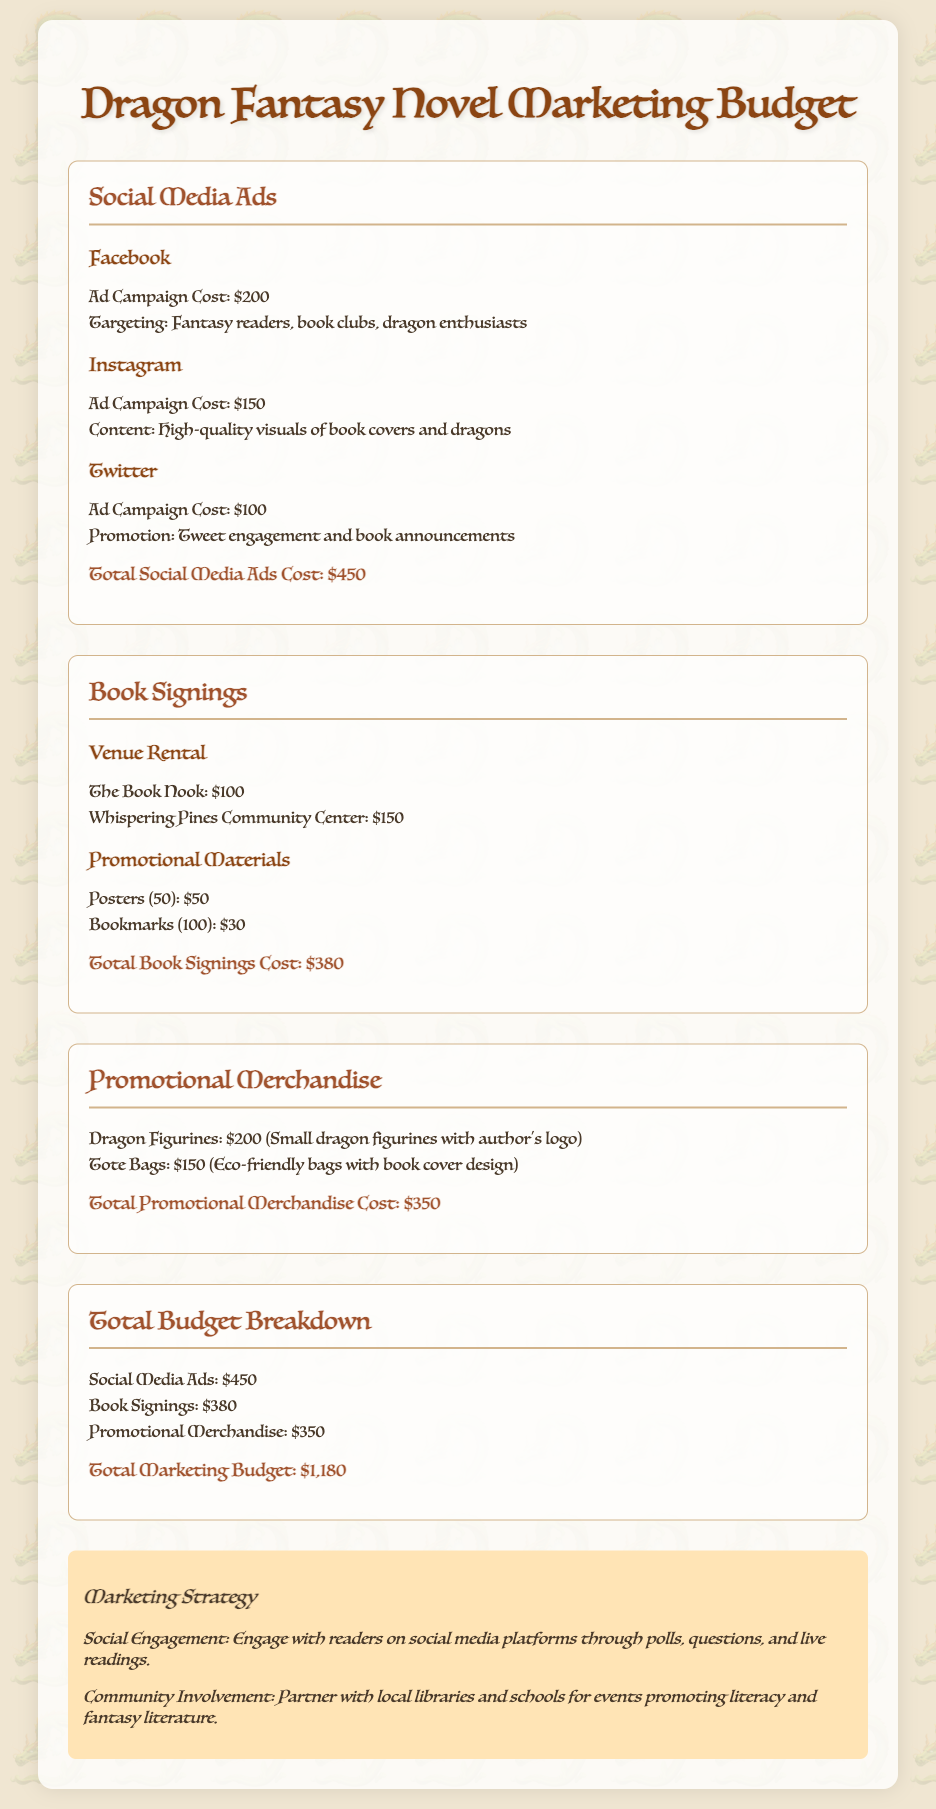What is the total cost for social media ads? The total cost for social media ads is stated as the sum of all ad campaign costs, which is $200 + $150 + $100.
Answer: $450 What are the two platforms mentioned for social media ads? The document mentions Facebook and Instagram as two of the platforms for social media ads.
Answer: Facebook, Instagram How much do the dragon figurines cost? The cost of dragon figurines is explicitly mentioned in the document as a single item.
Answer: $200 What is the total cost for book signings? The total cost for book signings is given as the aggregate of venue rental and promotional materials.
Answer: $380 How many posters are included in the promotional materials? The document specifies the quantity of posters listed under promotional materials in the book signings section.
Answer: 50 What is the total marketing budget? The document clearly states the total marketing budget as the sum of all categorized costs.
Answer: $1,180 What is one strategy mentioned to engage with readers? The document highlights a specific marketing strategy aimed at reader engagement detailed in the marketing strategy section.
Answer: Social Engagement Which item is not included in promotional merchandise? The document explicitly lists items included in promotional merchandise, allowing deduction of exclusions.
Answer: None (all listed) 